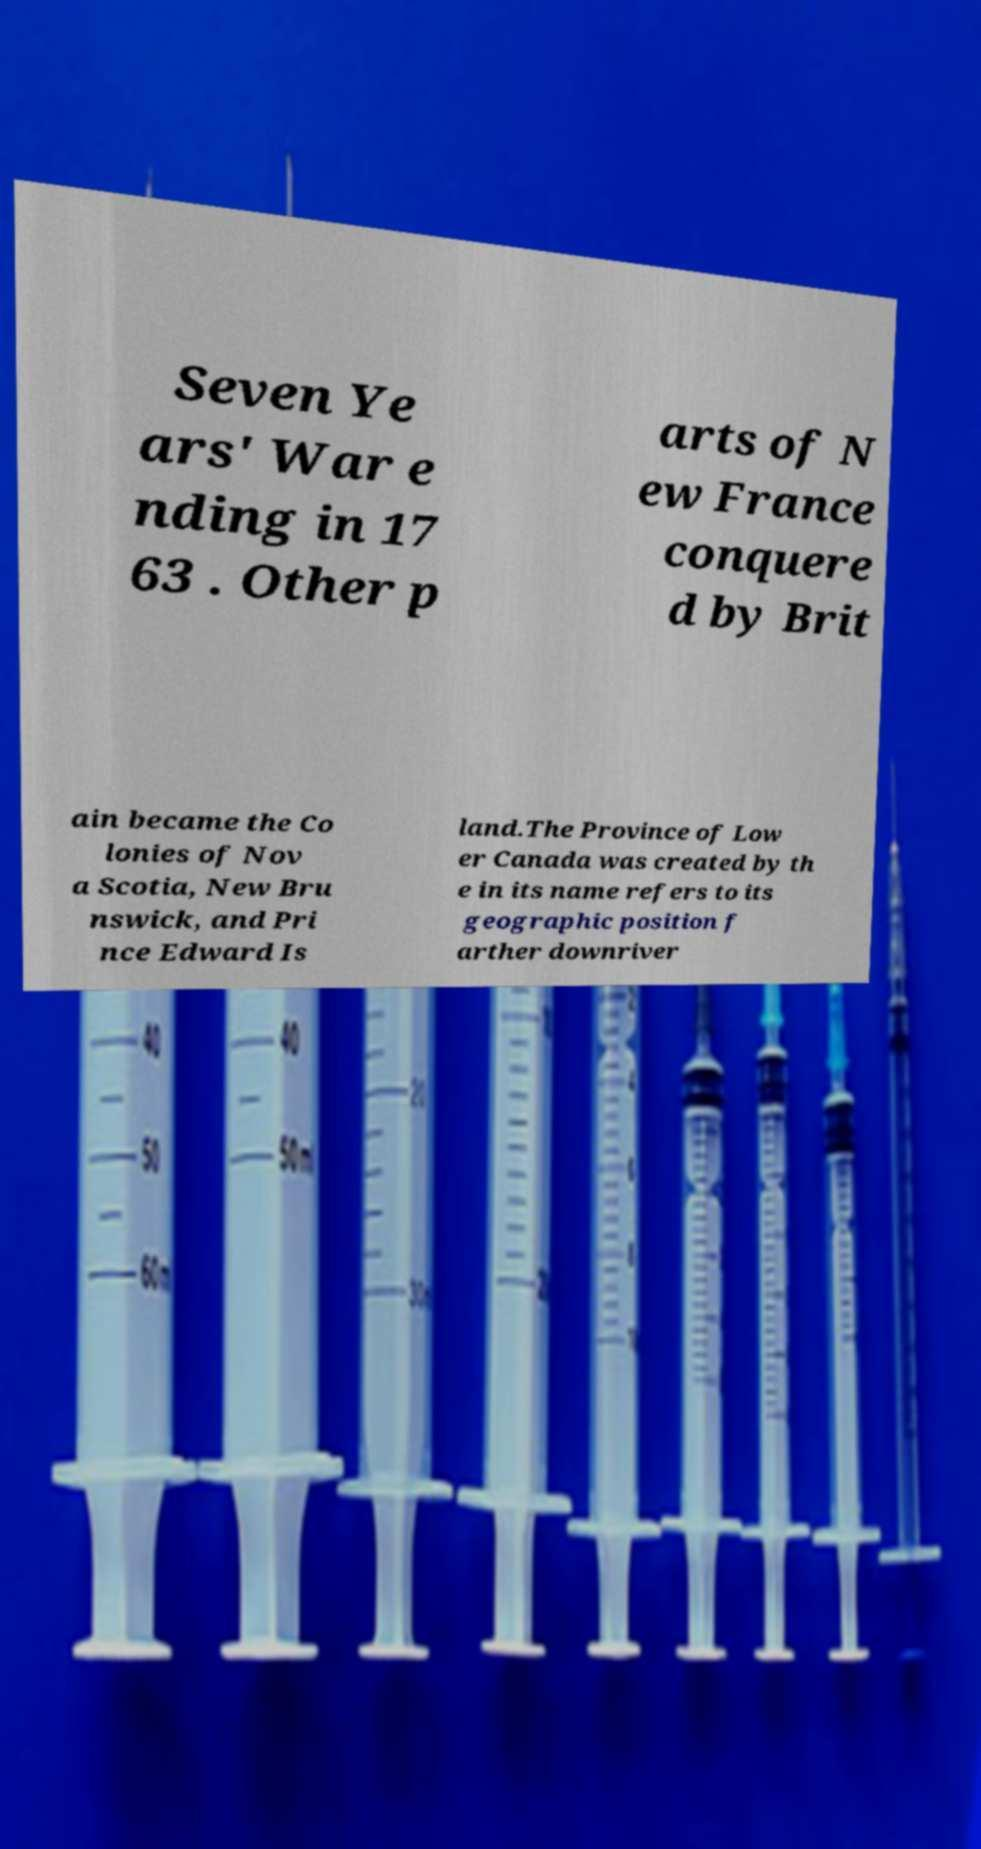Please identify and transcribe the text found in this image. Seven Ye ars' War e nding in 17 63 . Other p arts of N ew France conquere d by Brit ain became the Co lonies of Nov a Scotia, New Bru nswick, and Pri nce Edward Is land.The Province of Low er Canada was created by th e in its name refers to its geographic position f arther downriver 